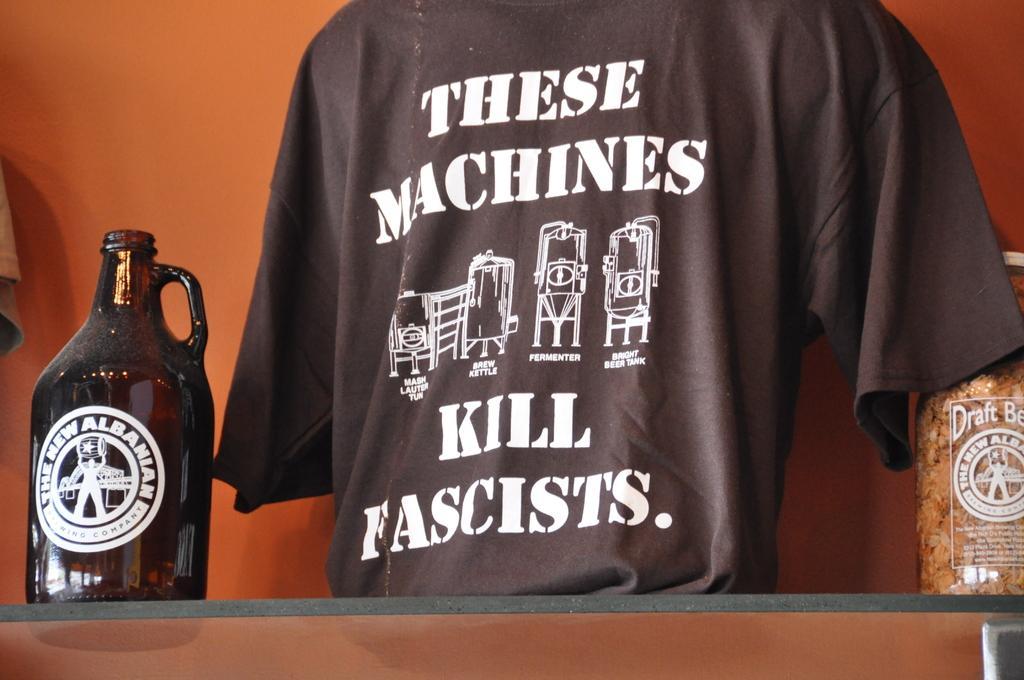Please provide a concise description of this image. In the image there is a glass jar on a glass shelf and a t-shirt beside it. 